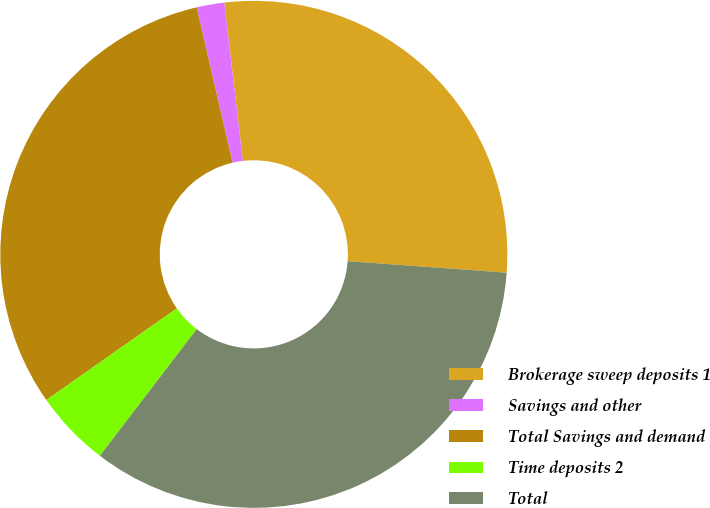Convert chart to OTSL. <chart><loc_0><loc_0><loc_500><loc_500><pie_chart><fcel>Brokerage sweep deposits 1<fcel>Savings and other<fcel>Total Savings and demand<fcel>Time deposits 2<fcel>Total<nl><fcel>28.01%<fcel>1.76%<fcel>31.12%<fcel>4.87%<fcel>34.23%<nl></chart> 